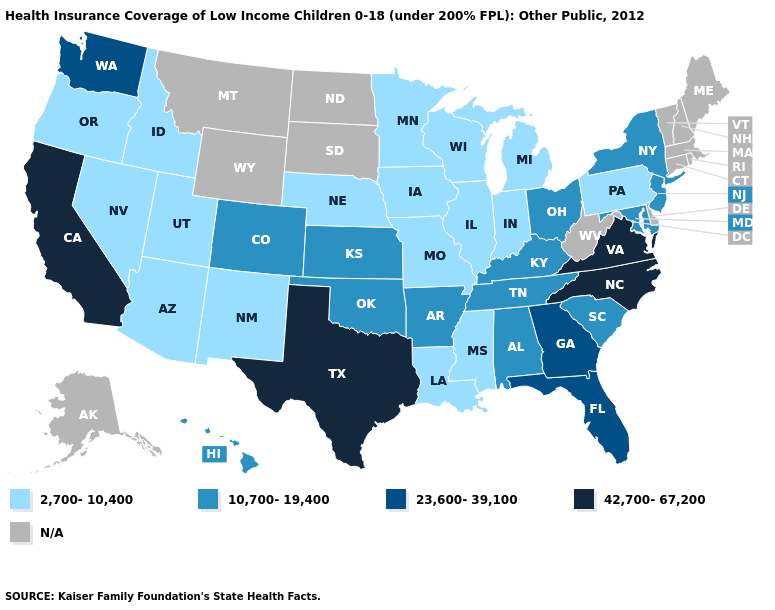Which states have the lowest value in the South?
Give a very brief answer. Louisiana, Mississippi. Which states have the lowest value in the USA?
Short answer required. Arizona, Idaho, Illinois, Indiana, Iowa, Louisiana, Michigan, Minnesota, Mississippi, Missouri, Nebraska, Nevada, New Mexico, Oregon, Pennsylvania, Utah, Wisconsin. What is the value of New Hampshire?
Write a very short answer. N/A. Which states have the highest value in the USA?
Concise answer only. California, North Carolina, Texas, Virginia. Does Texas have the highest value in the USA?
Concise answer only. Yes. Among the states that border Indiana , does Illinois have the highest value?
Short answer required. No. Name the states that have a value in the range N/A?
Keep it brief. Alaska, Connecticut, Delaware, Maine, Massachusetts, Montana, New Hampshire, North Dakota, Rhode Island, South Dakota, Vermont, West Virginia, Wyoming. What is the value of Arizona?
Write a very short answer. 2,700-10,400. What is the value of North Carolina?
Concise answer only. 42,700-67,200. Does Michigan have the highest value in the MidWest?
Write a very short answer. No. What is the value of Pennsylvania?
Answer briefly. 2,700-10,400. Name the states that have a value in the range 42,700-67,200?
Short answer required. California, North Carolina, Texas, Virginia. What is the value of Nevada?
Be succinct. 2,700-10,400. 